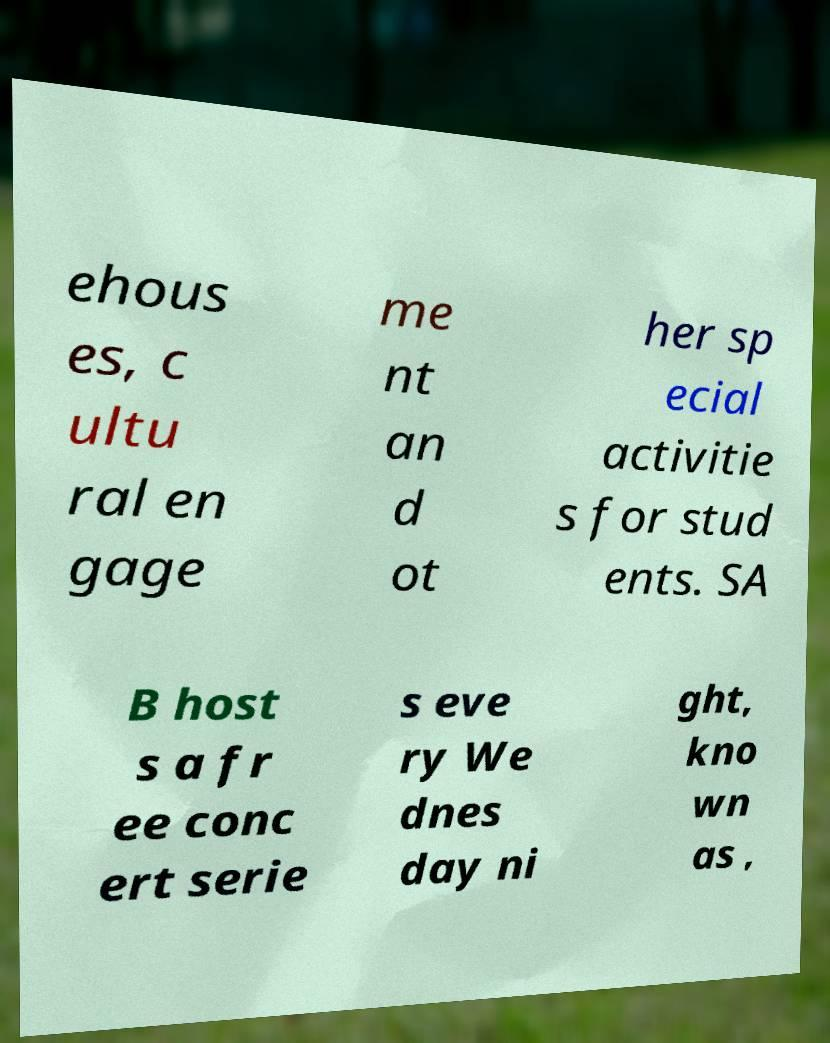Could you extract and type out the text from this image? ehous es, c ultu ral en gage me nt an d ot her sp ecial activitie s for stud ents. SA B host s a fr ee conc ert serie s eve ry We dnes day ni ght, kno wn as , 